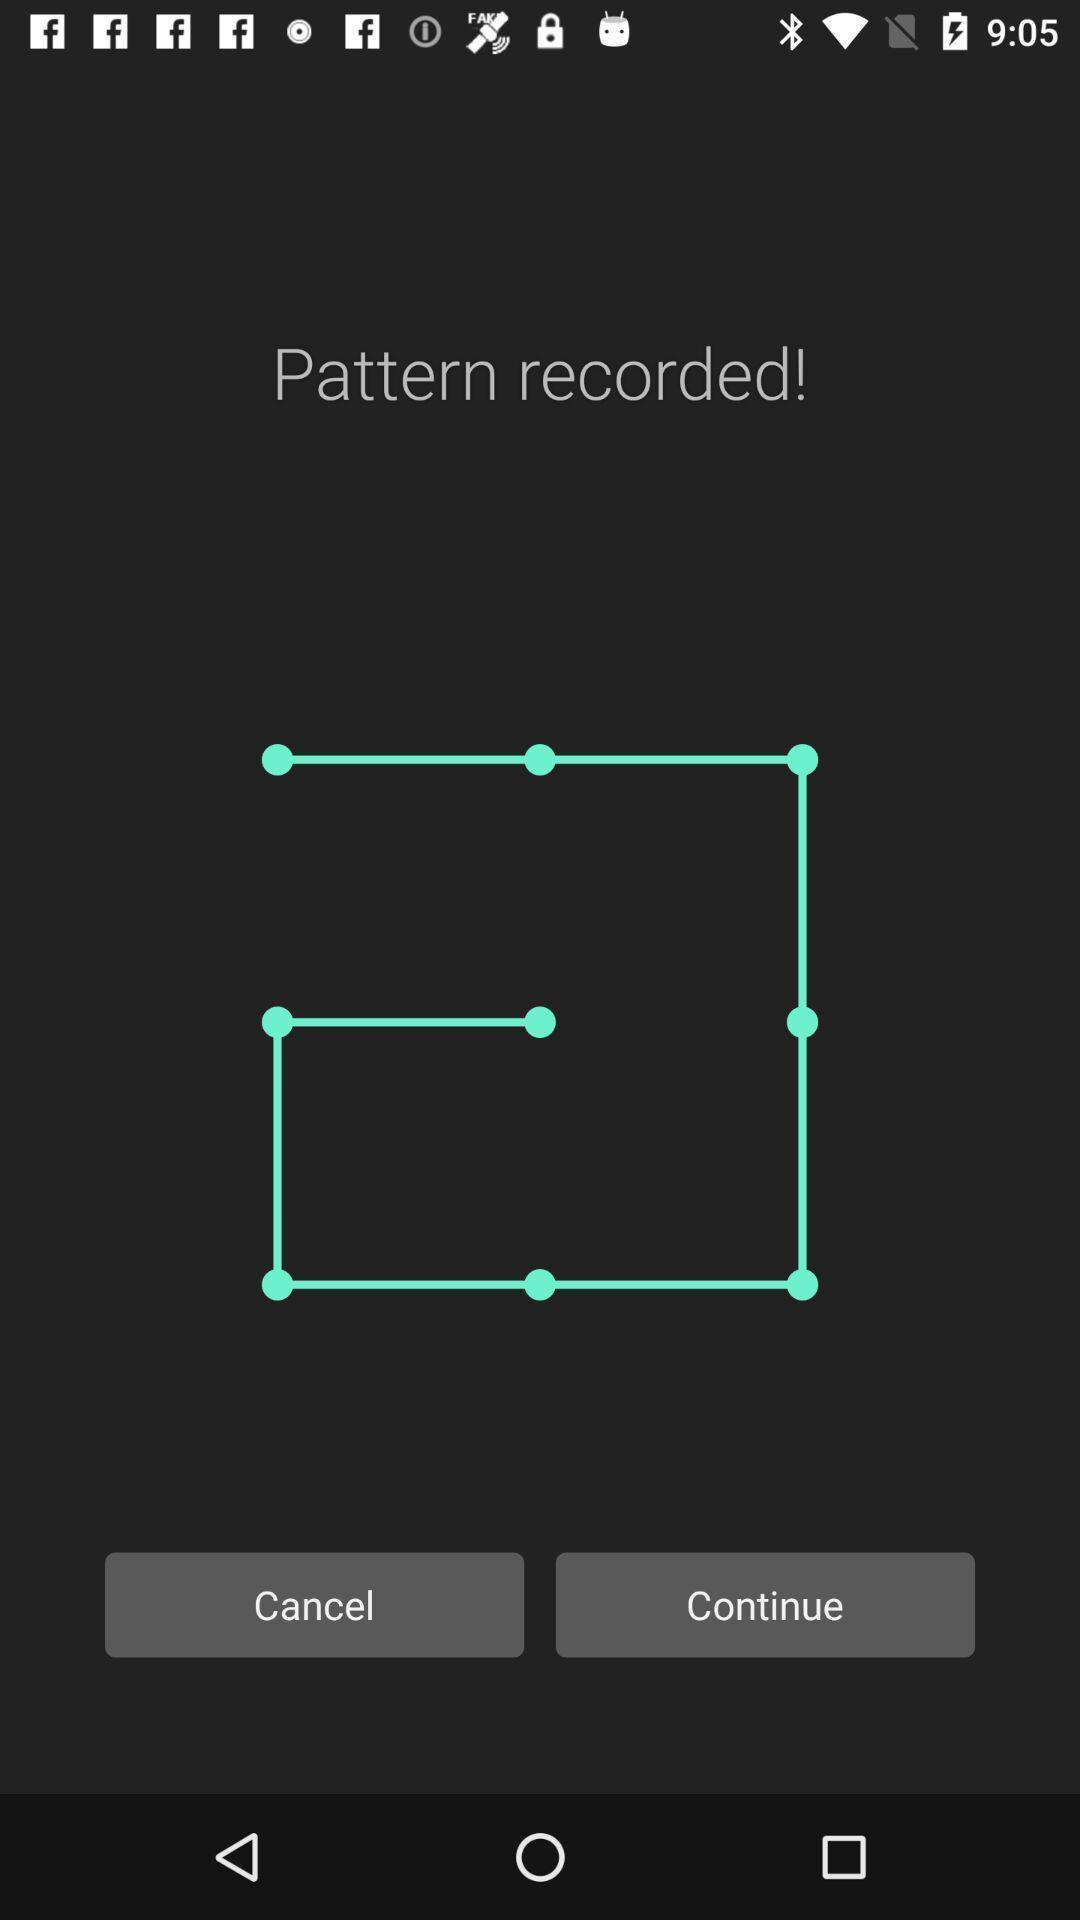What can you discern from this picture? Screen lock pattern setting in the mobile. 